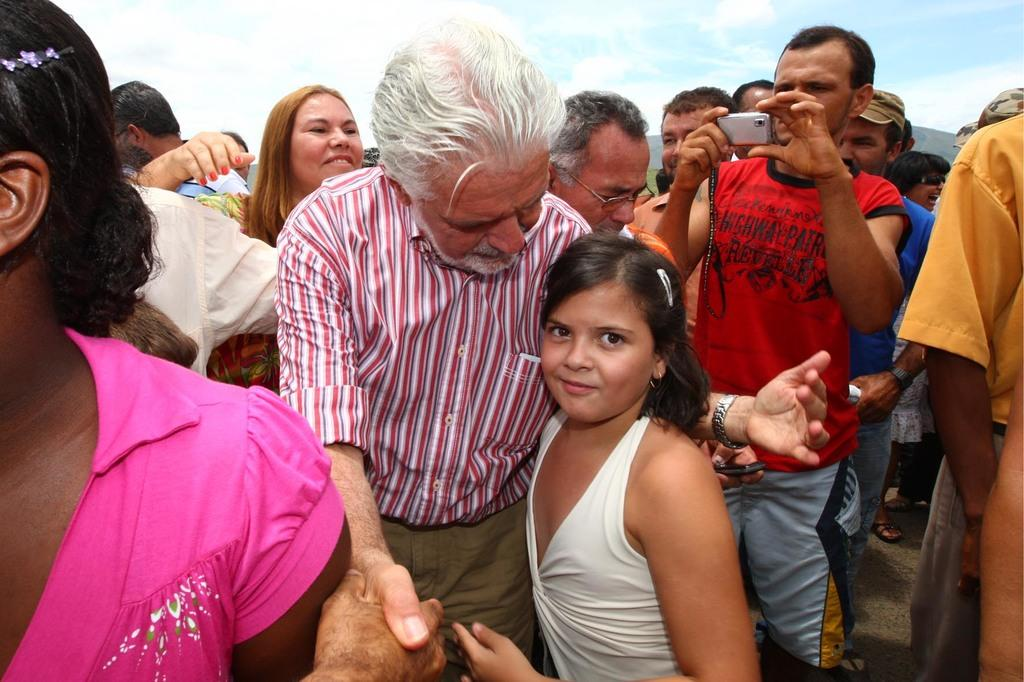What is the main subject of the image? The main subject of the image is a group of people. Can you describe the man in the group? The man in the group is standing and holding a camera. What is visible at the top of the image? The sky is visible at the top of the image. What type of statement is the man making while holding the camera in the image? There is no indication in the image that the man is making a statement while holding the camera. 